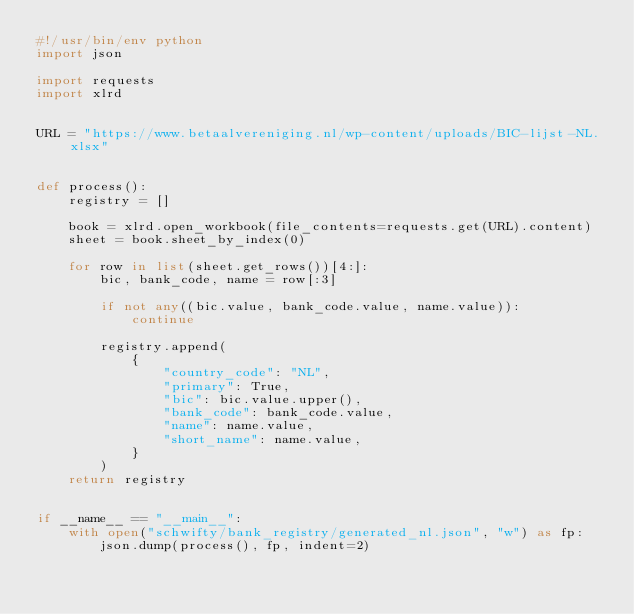Convert code to text. <code><loc_0><loc_0><loc_500><loc_500><_Python_>#!/usr/bin/env python
import json

import requests
import xlrd


URL = "https://www.betaalvereniging.nl/wp-content/uploads/BIC-lijst-NL.xlsx"


def process():
    registry = []

    book = xlrd.open_workbook(file_contents=requests.get(URL).content)
    sheet = book.sheet_by_index(0)

    for row in list(sheet.get_rows())[4:]:
        bic, bank_code, name = row[:3]

        if not any((bic.value, bank_code.value, name.value)):
            continue

        registry.append(
            {
                "country_code": "NL",
                "primary": True,
                "bic": bic.value.upper(),
                "bank_code": bank_code.value,
                "name": name.value,
                "short_name": name.value,
            }
        )
    return registry


if __name__ == "__main__":
    with open("schwifty/bank_registry/generated_nl.json", "w") as fp:
        json.dump(process(), fp, indent=2)
</code> 